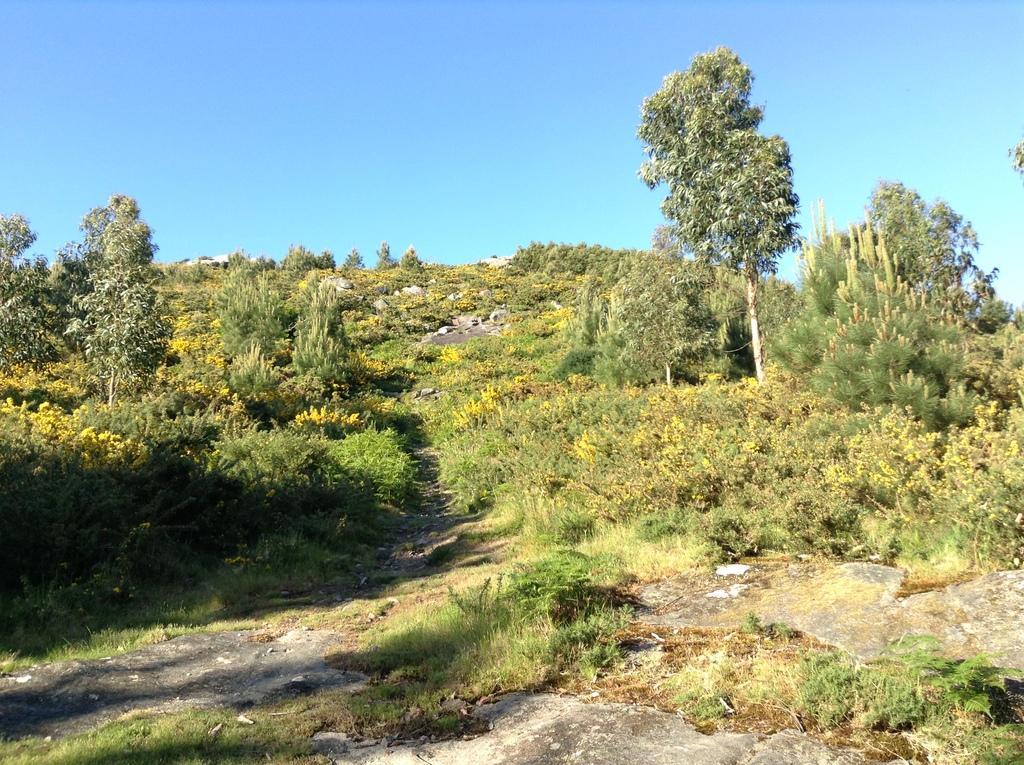Could you give a brief overview of what you see in this image? In this image, we can see the ground. We can see some grass, plants and trees. We can also see some rocks and the sky. 